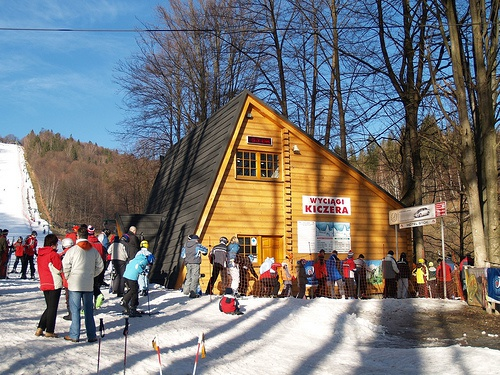Describe the objects in this image and their specific colors. I can see people in darkgray, black, gray, maroon, and white tones, people in darkgray, gray, ivory, and black tones, people in darkgray, black, red, and ivory tones, people in darkgray, black, lightblue, and gray tones, and people in darkgray, gray, black, and lightgray tones in this image. 